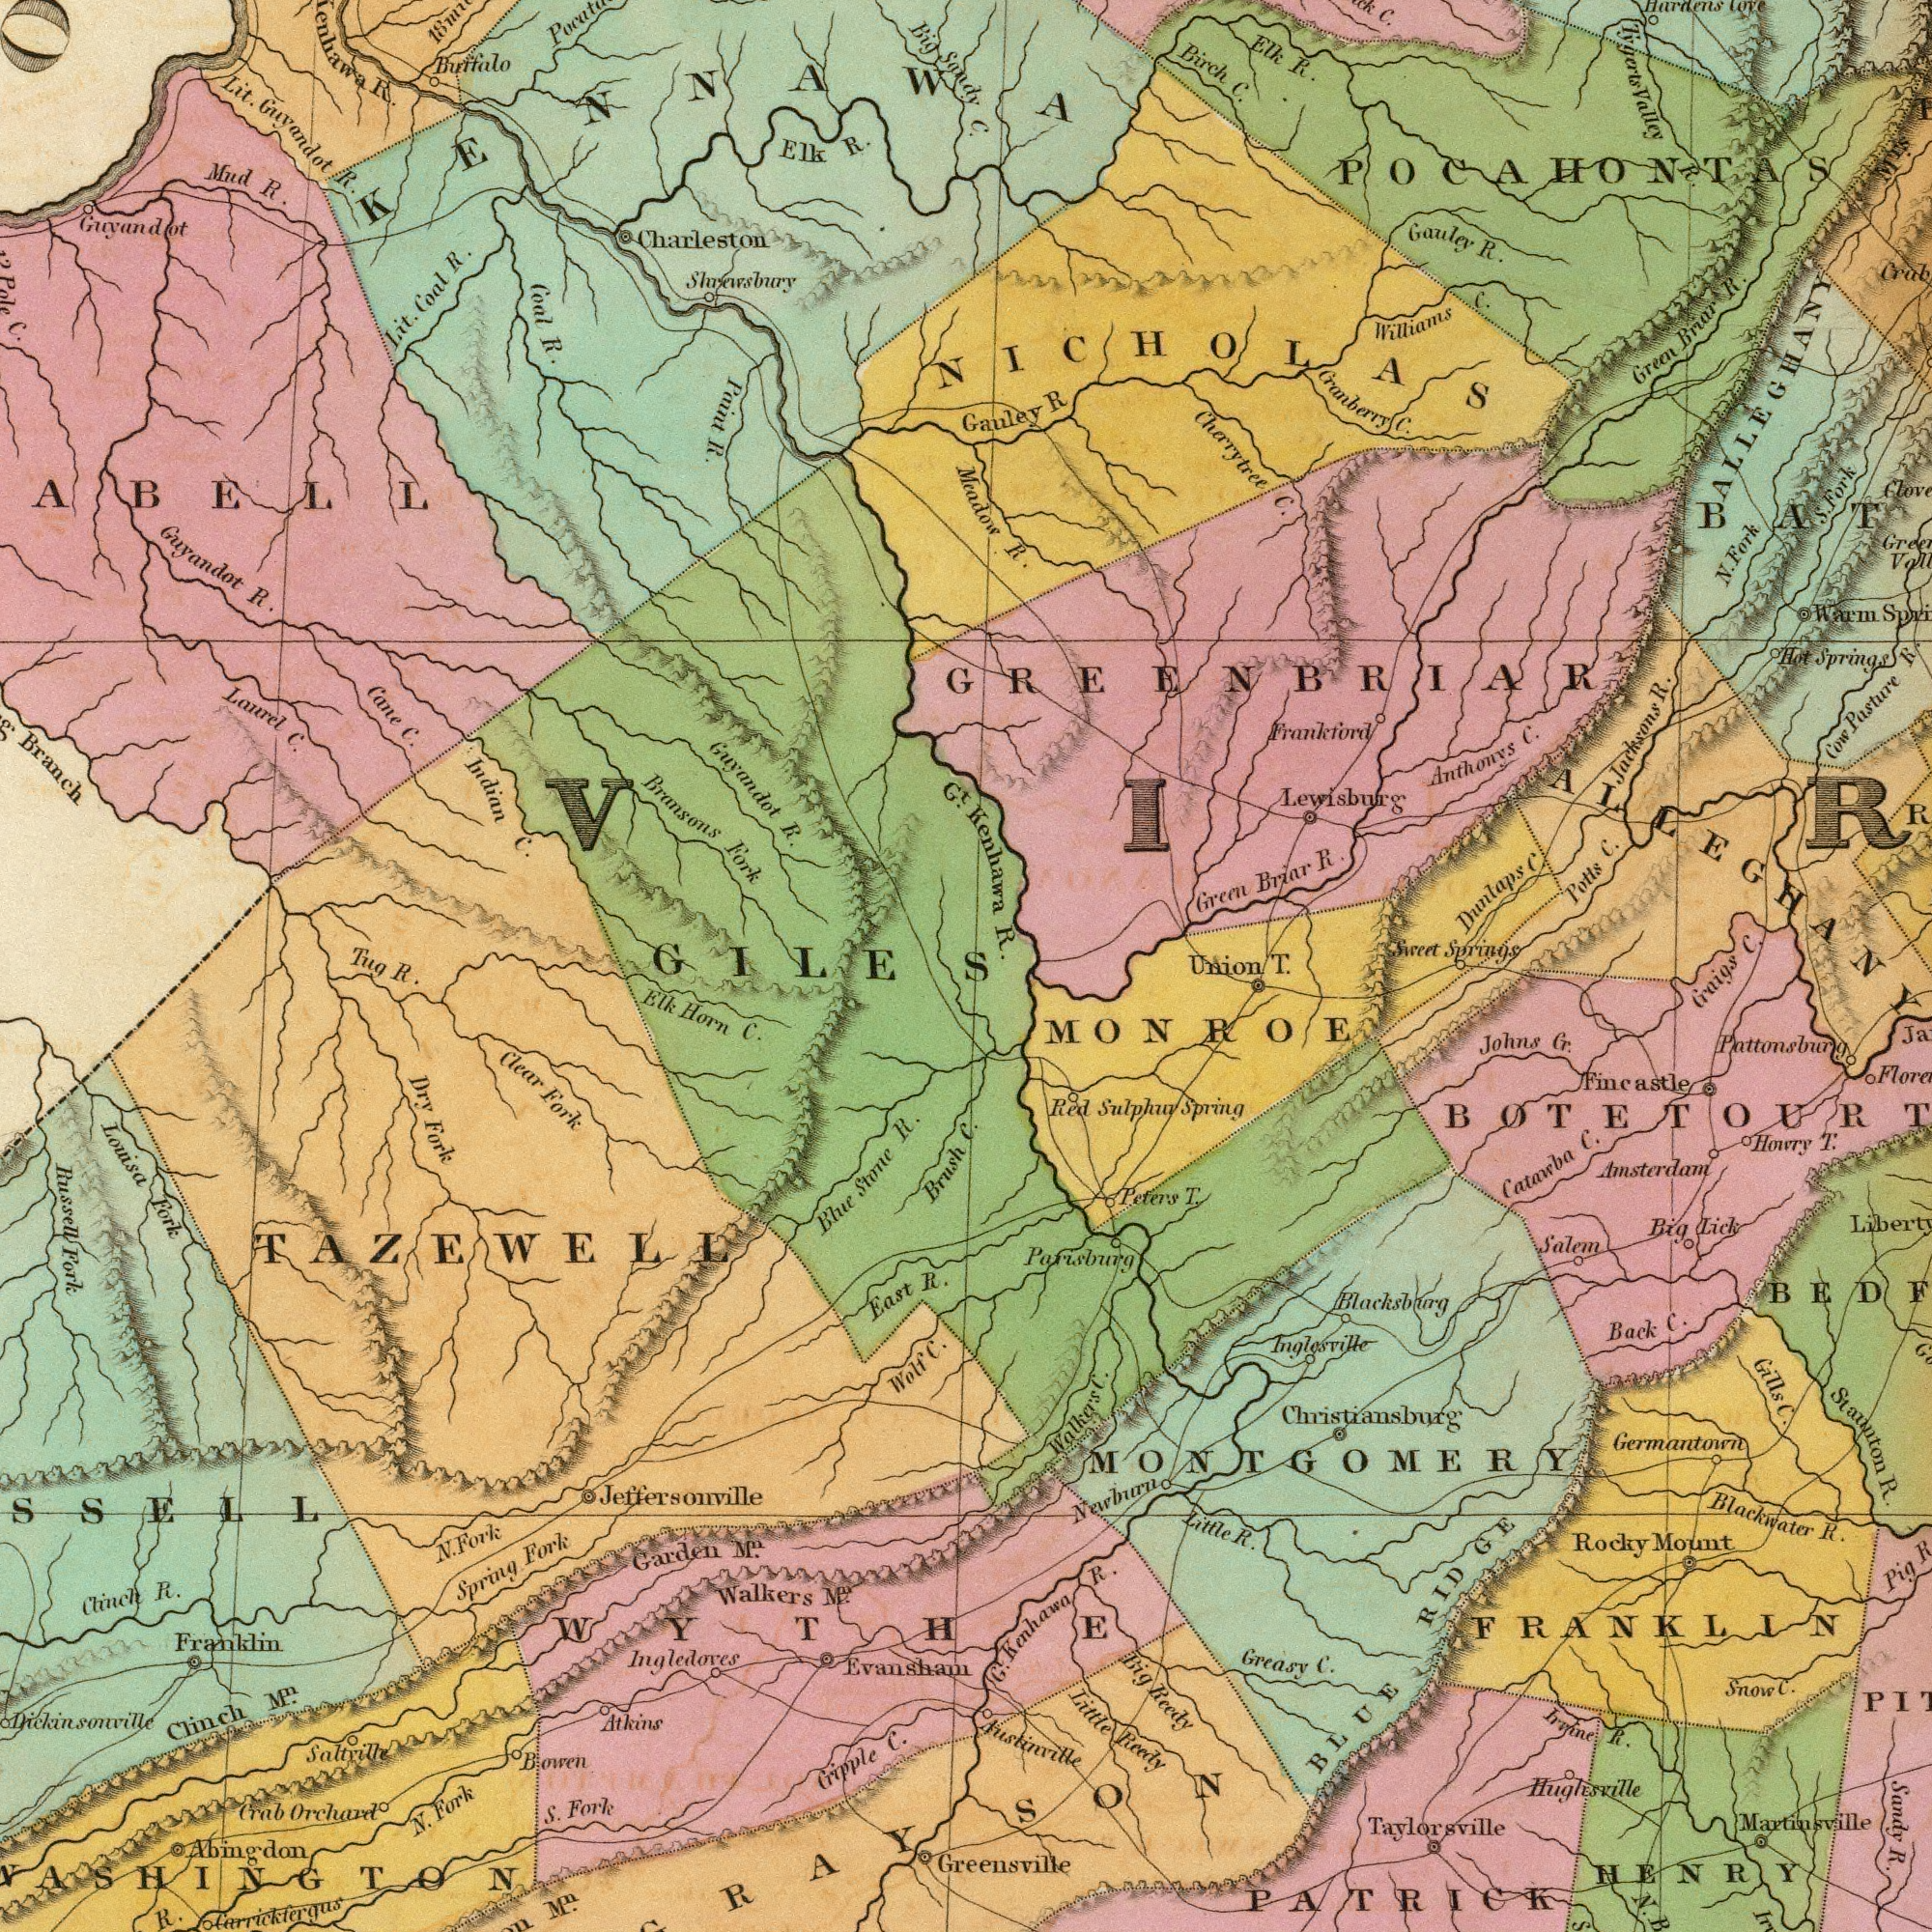What text is visible in the lower-right corner? Craigs C. Germantoint Austinville Taylorsville Pattonsburg MONROE Red Sulphuv Spring Parisburg Johns Cr. Staunton R. Sandy R. Big Lick Salem G. Kenhawa R. Back C. Christiansburg Gills C. Blacksburg Inglesvile Hughesville Amsterdam Catarba C. Little Reedy Peters T. Greasy C. Rocky Mount PATRICK Blackwater R. Irvine R. Pig Fincastle Little R. Big Reedy Martinsville FRANKLIN Howry T. RIDGE Snow C. Walker's C. MONTGOMERY HENRY Nawburn BLUE Greensville What text can you see in the top-left section? Coal R. Guyandot R. Charleston R. Cane C. Guyandot R. Bransons Fork Indian C. Lit. Guyandot R. Branch Elk R. Mud R. Lit. Coal R. Guyandot Buffalo Shrewsbury Lanrel C. Pole C. Paint R. Gt. ###ABELL Big Sandy Tug KENNAWA GILES What text is visible in the lower-left corner? Ingledoves Walkers Mn. Dry Fork Louisa Fork Russell Fork Mn. Elk Horn C. Jeffersonville N. Fork Brush East R. Evansham Chinch R. Crab Orchard Blue Stone R. Clear Fork S. Fork Spring Fork Atkins Saltville Bowen Abingdon Clinch Mn. Wolf C. Garden Mn. Cripple C. Franklin N. Fork Dickinssnville R. Carrickfergus TAZEWELL WYTHE What text can you see in the top-right section? Kenhawa R. C. Green Briar R. Lewisburg Cherrytree C. Mcadow R. Birch C. Elk R. Green Briar R. Gauley R. Anthonys C. Street Springs Potts C. Williams C. Dunlaps C. Frankford Gauley R Hot Springs Cow Pasture R. Cranberry C. C. Warm S. Fork Jacksons R. Tygerts Valley R. ALLEGHANY MTS. C. Hardens Cove GREENBRIAR POCAHONTAS N. Fork NICHOLAS Union T. 